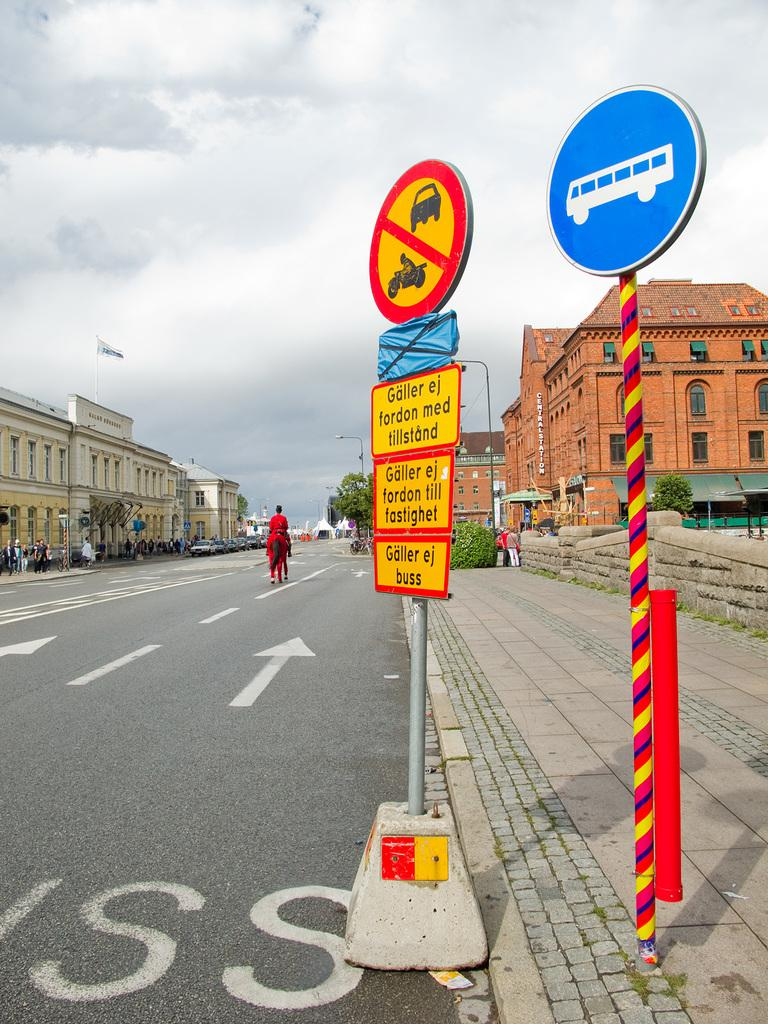<image>
Describe the image concisely. A bunch of signs, one of which reads Galler ej fordon med tillstand. 